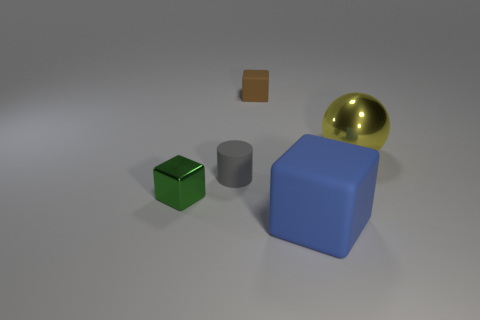Do the yellow thing and the gray rubber object have the same shape?
Your answer should be very brief. No. How many other objects are the same material as the large yellow ball?
Ensure brevity in your answer.  1. Is there a thing that is to the left of the large thing that is right of the blue matte cube?
Keep it short and to the point. Yes. Is there anything else that has the same shape as the large yellow shiny object?
Give a very brief answer. No. The other big rubber thing that is the same shape as the brown thing is what color?
Provide a short and direct response. Blue. What is the size of the gray object?
Your response must be concise. Small. Is the number of brown blocks that are behind the brown rubber block less than the number of large metal objects?
Your response must be concise. Yes. Does the gray cylinder have the same material as the large object behind the gray rubber cylinder?
Make the answer very short. No. There is a large object that is in front of the metallic object that is in front of the large metal object; is there a large block behind it?
Provide a succinct answer. No. What color is the cube that is made of the same material as the large blue thing?
Your response must be concise. Brown. 